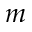<formula> <loc_0><loc_0><loc_500><loc_500>m</formula> 